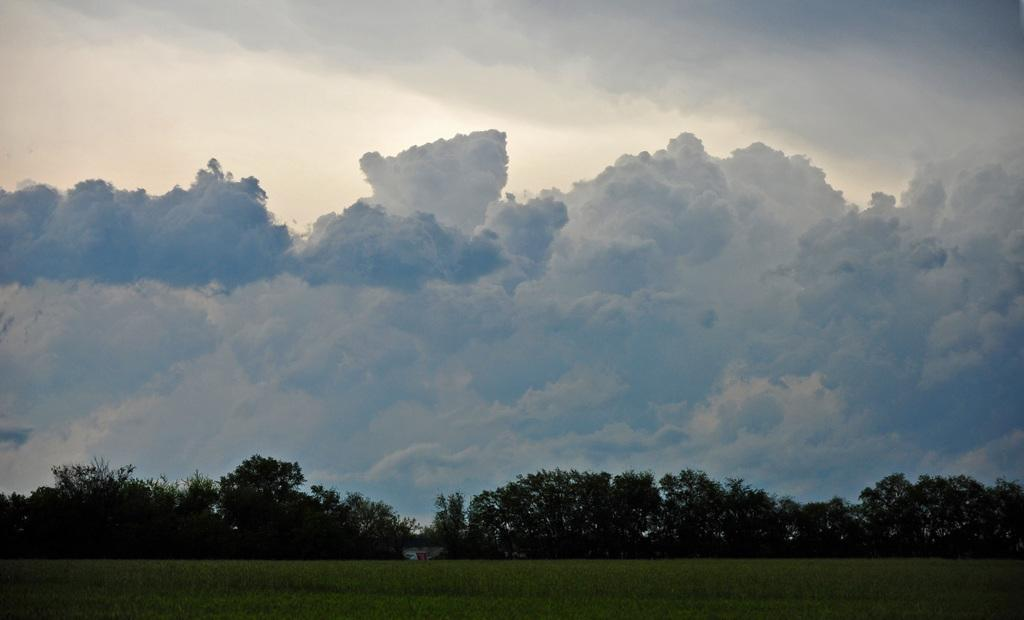What type of vegetation is present on the ground in the image? There is grass on the ground in the image. What other natural elements can be seen in the image? There are trees in the image. What is visible in the background of the image? The sky is visible in the background of the image. What can be observed in the sky? There are clouds in the sky. What route does the passenger take to reach the destination in the image? There is no passenger or destination present in the image; it features grass, trees, and a sky with clouds. What specific detail can be observed about the clouds in the image? The provided facts do not mention any specific details about the clouds, only that they are present in the sky. 